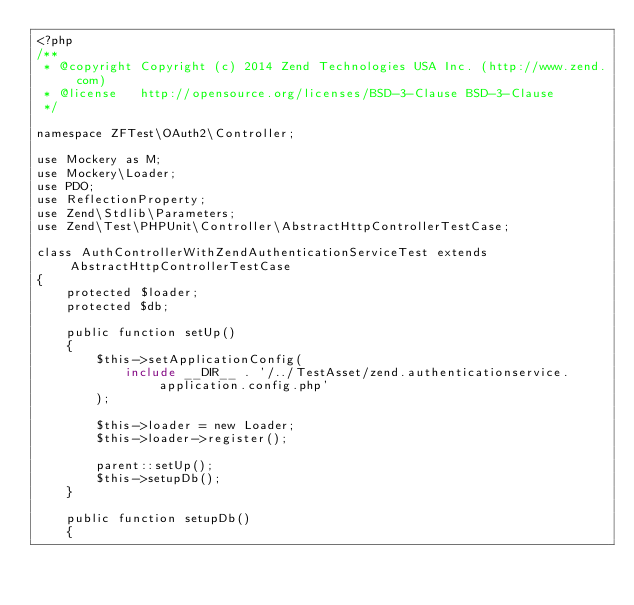Convert code to text. <code><loc_0><loc_0><loc_500><loc_500><_PHP_><?php
/**
 * @copyright Copyright (c) 2014 Zend Technologies USA Inc. (http://www.zend.com)
 * @license   http://opensource.org/licenses/BSD-3-Clause BSD-3-Clause
 */

namespace ZFTest\OAuth2\Controller;

use Mockery as M;
use Mockery\Loader;
use PDO;
use ReflectionProperty;
use Zend\Stdlib\Parameters;
use Zend\Test\PHPUnit\Controller\AbstractHttpControllerTestCase;

class AuthControllerWithZendAuthenticationServiceTest extends AbstractHttpControllerTestCase
{
    protected $loader;
    protected $db;

    public function setUp()
    {
        $this->setApplicationConfig(
            include __DIR__ . '/../TestAsset/zend.authenticationservice.application.config.php'
        );

        $this->loader = new Loader;
        $this->loader->register();

        parent::setUp();
        $this->setupDb();
    }

    public function setupDb()
    {</code> 